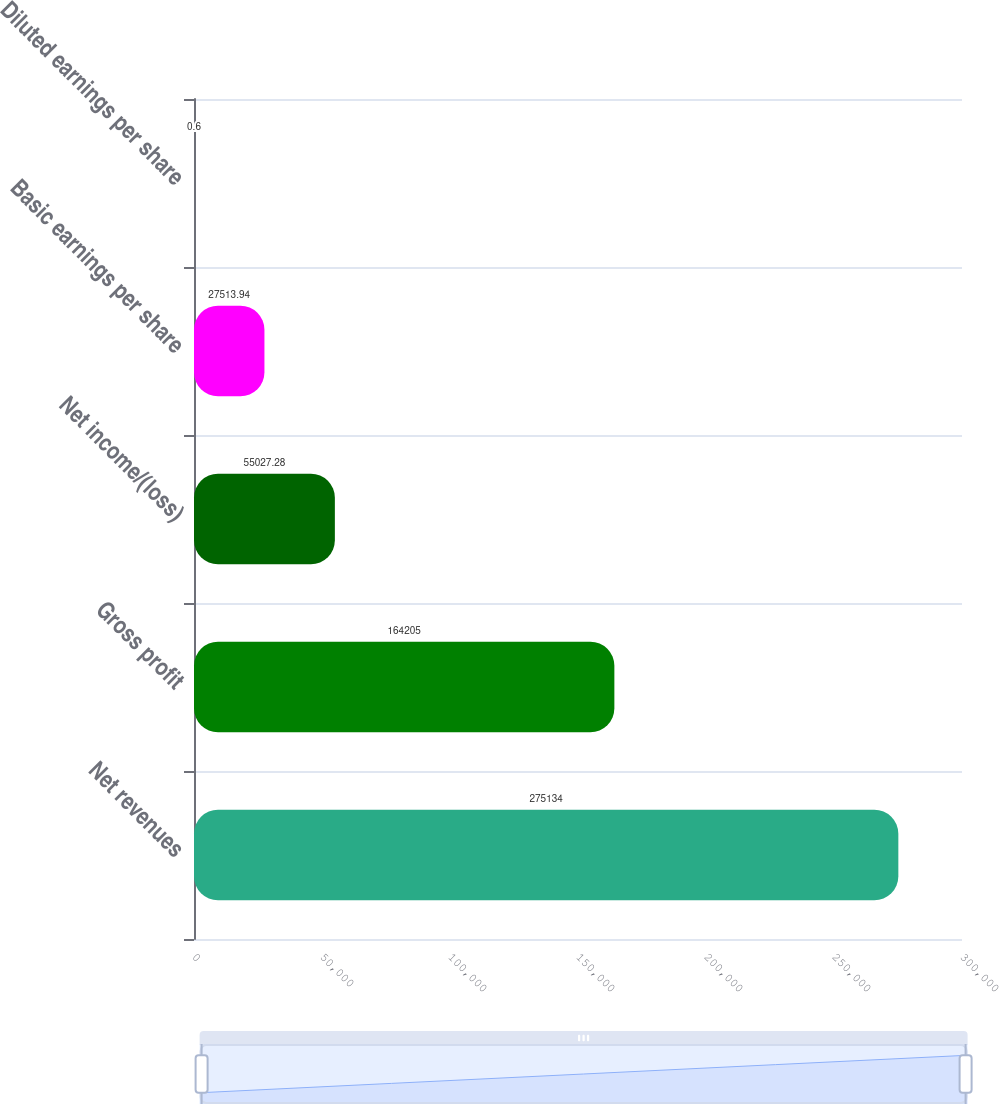<chart> <loc_0><loc_0><loc_500><loc_500><bar_chart><fcel>Net revenues<fcel>Gross profit<fcel>Net income/(loss)<fcel>Basic earnings per share<fcel>Diluted earnings per share<nl><fcel>275134<fcel>164205<fcel>55027.3<fcel>27513.9<fcel>0.6<nl></chart> 